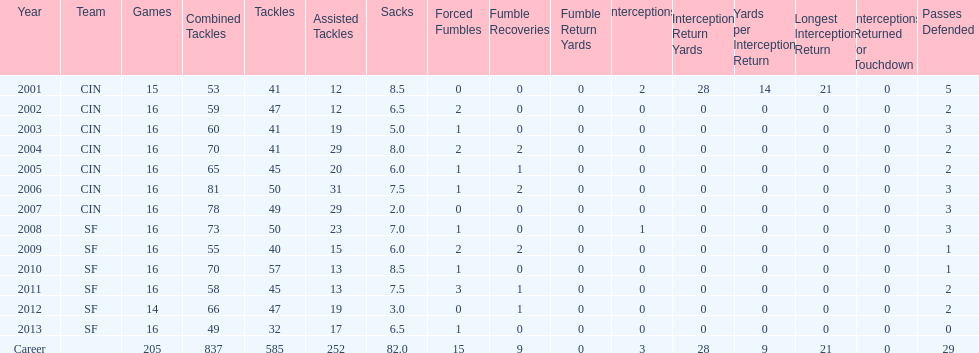How many years did he play without recovering a fumble? 7. 